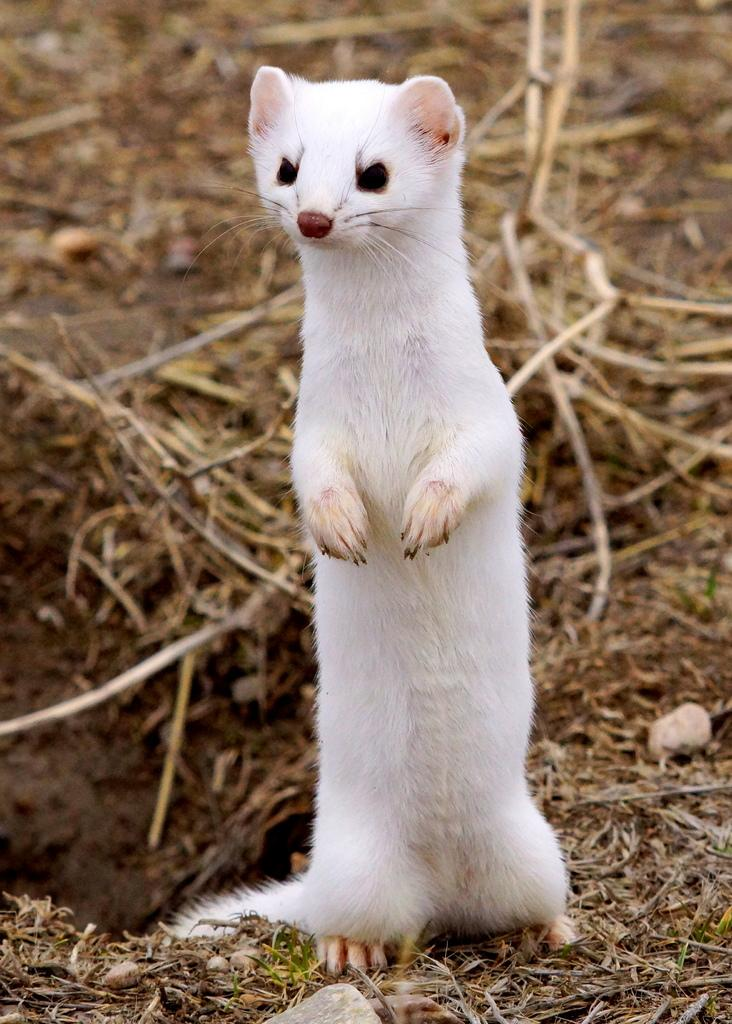What animal can be seen in the image? There is a weasel in the image. What is the weasel's position in the image? The weasel is standing on the ground. What type of objects can be seen in the background of the image? There are wooden sticks in the background of the image. What type of terrain is visible in the image? There is sand and stones on the ground in the image. Can you tell me how the weasel is connected to its sister in the image? There is no mention of a sister or any connection between the weasel and another individual in the image. 